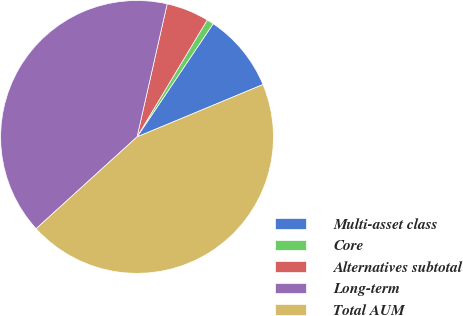<chart> <loc_0><loc_0><loc_500><loc_500><pie_chart><fcel>Multi-asset class<fcel>Core<fcel>Alternatives subtotal<fcel>Long-term<fcel>Total AUM<nl><fcel>9.3%<fcel>0.82%<fcel>5.06%<fcel>40.29%<fcel>44.53%<nl></chart> 